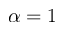<formula> <loc_0><loc_0><loc_500><loc_500>\alpha = 1</formula> 